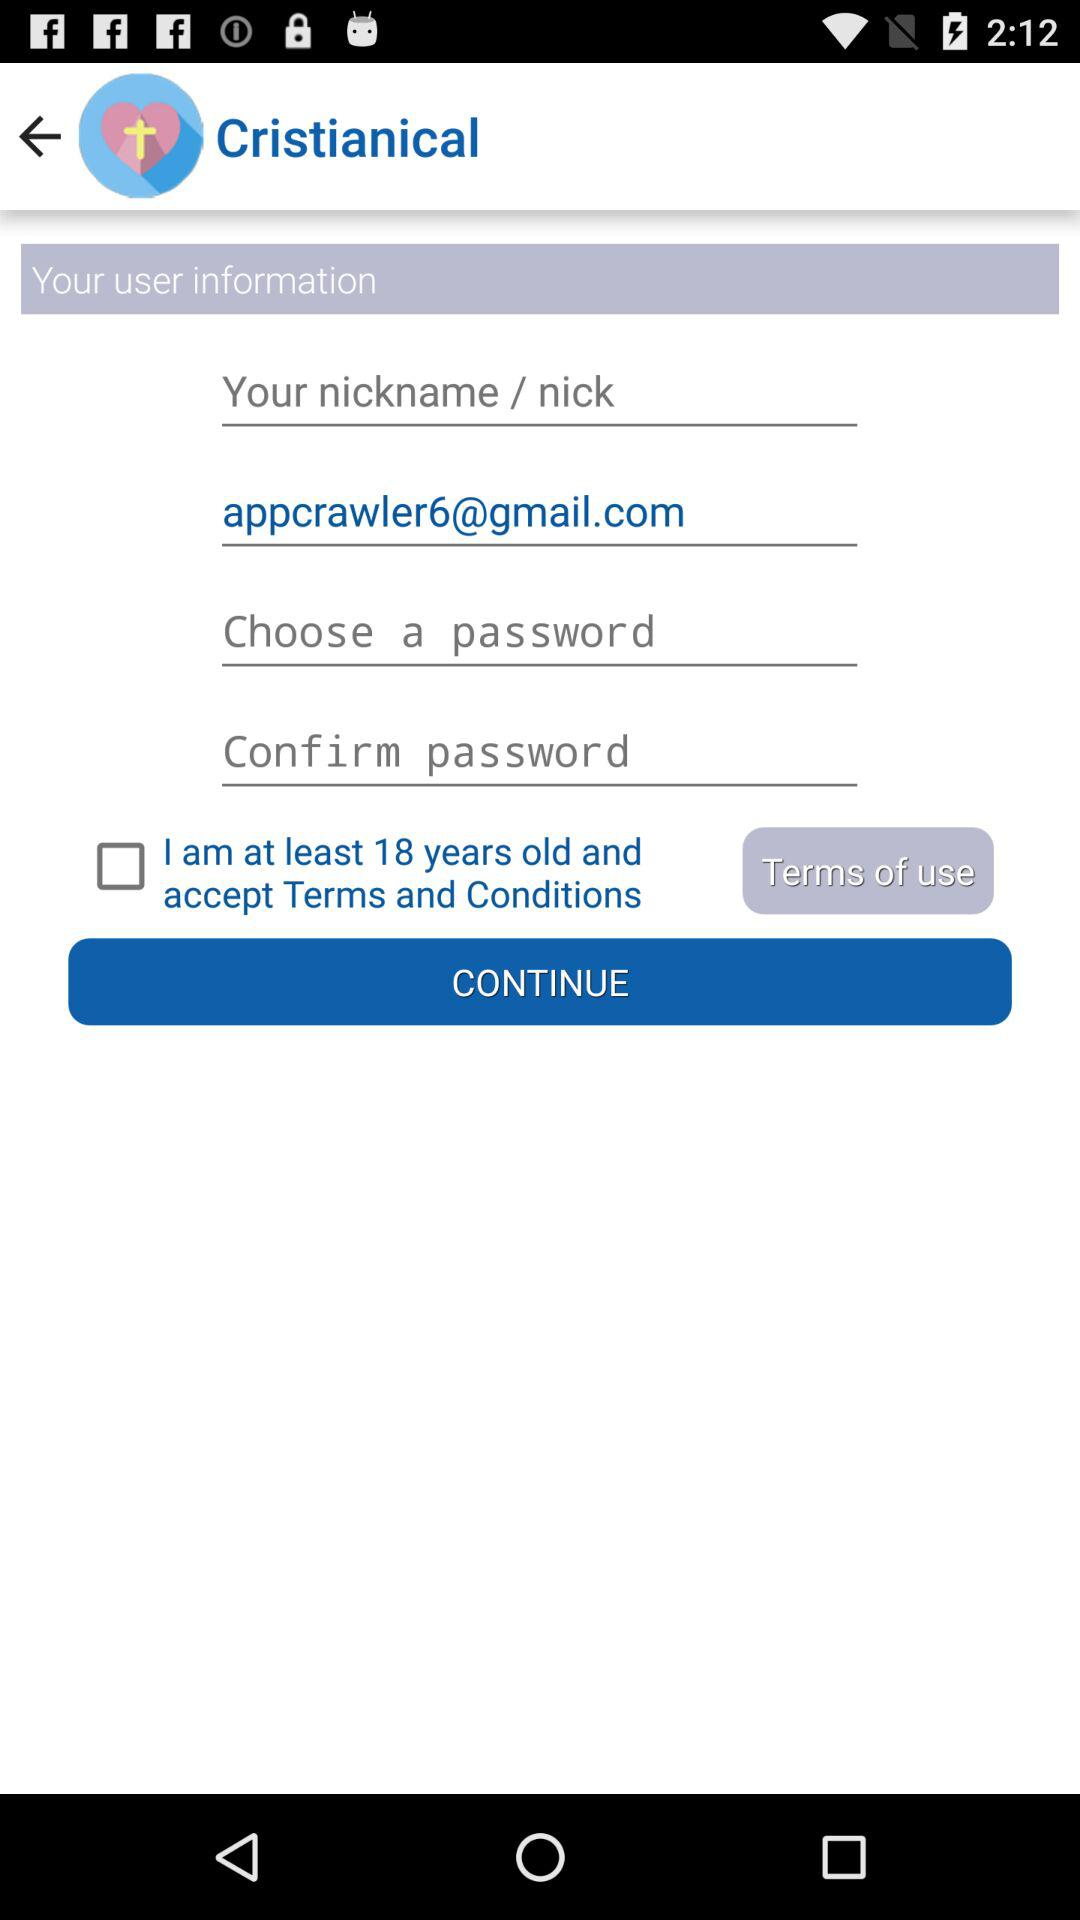What's the status of the terms and conditions? The status is "off". 